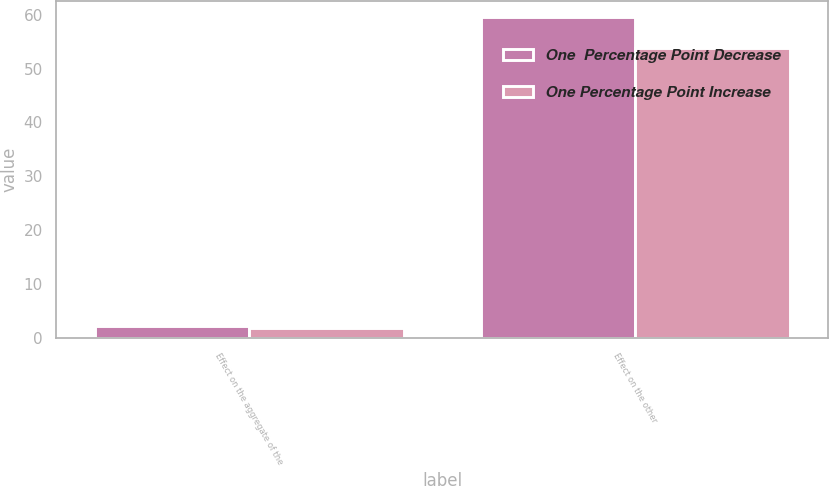Convert chart to OTSL. <chart><loc_0><loc_0><loc_500><loc_500><stacked_bar_chart><ecel><fcel>Effect on the aggregate of the<fcel>Effect on the other<nl><fcel>One  Percentage Point Decrease<fcel>2.2<fcel>59.5<nl><fcel>One Percentage Point Increase<fcel>1.9<fcel>53.8<nl></chart> 